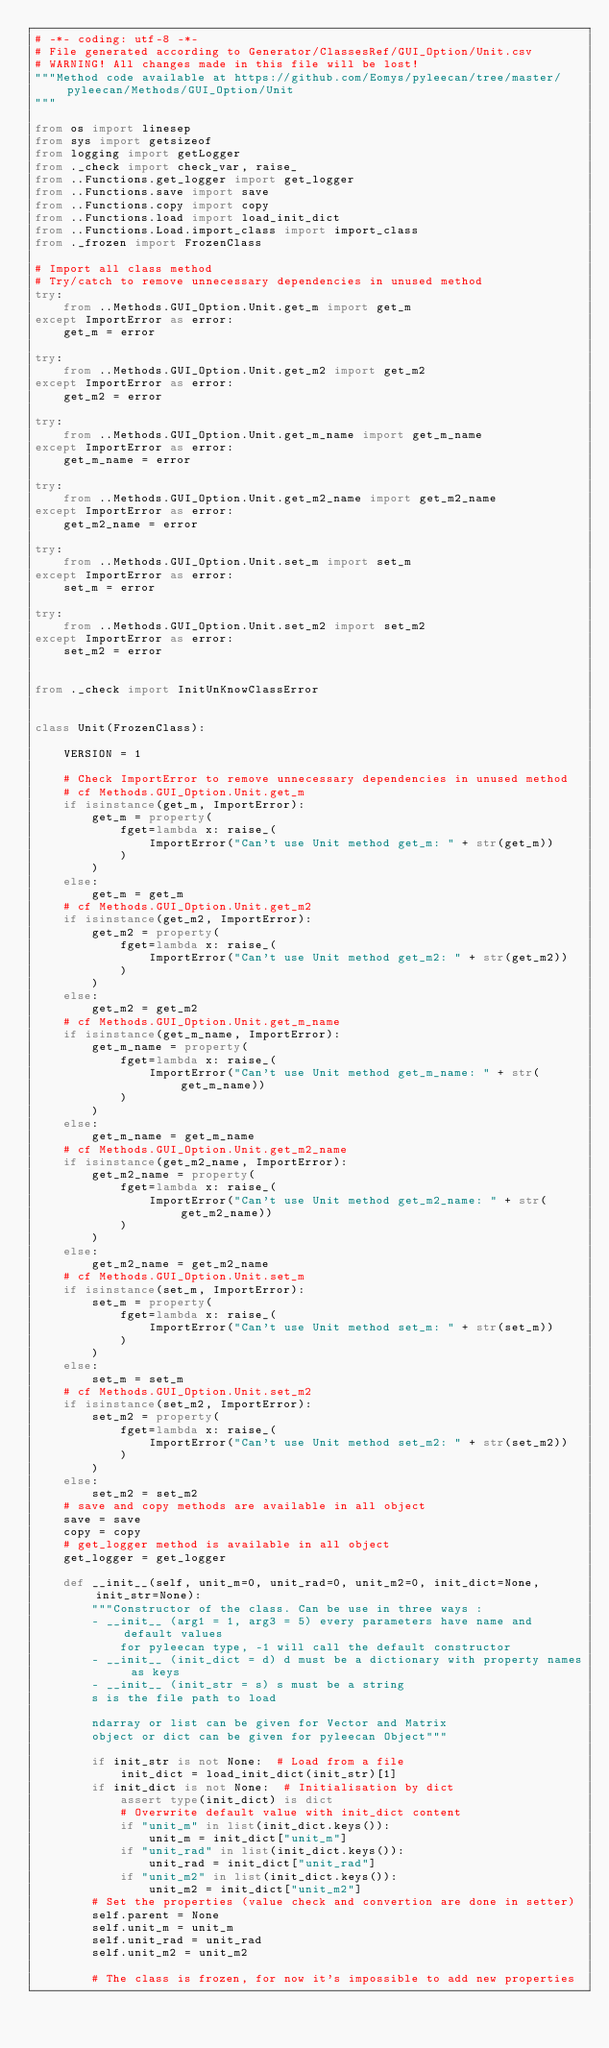Convert code to text. <code><loc_0><loc_0><loc_500><loc_500><_Python_># -*- coding: utf-8 -*-
# File generated according to Generator/ClassesRef/GUI_Option/Unit.csv
# WARNING! All changes made in this file will be lost!
"""Method code available at https://github.com/Eomys/pyleecan/tree/master/pyleecan/Methods/GUI_Option/Unit
"""

from os import linesep
from sys import getsizeof
from logging import getLogger
from ._check import check_var, raise_
from ..Functions.get_logger import get_logger
from ..Functions.save import save
from ..Functions.copy import copy
from ..Functions.load import load_init_dict
from ..Functions.Load.import_class import import_class
from ._frozen import FrozenClass

# Import all class method
# Try/catch to remove unnecessary dependencies in unused method
try:
    from ..Methods.GUI_Option.Unit.get_m import get_m
except ImportError as error:
    get_m = error

try:
    from ..Methods.GUI_Option.Unit.get_m2 import get_m2
except ImportError as error:
    get_m2 = error

try:
    from ..Methods.GUI_Option.Unit.get_m_name import get_m_name
except ImportError as error:
    get_m_name = error

try:
    from ..Methods.GUI_Option.Unit.get_m2_name import get_m2_name
except ImportError as error:
    get_m2_name = error

try:
    from ..Methods.GUI_Option.Unit.set_m import set_m
except ImportError as error:
    set_m = error

try:
    from ..Methods.GUI_Option.Unit.set_m2 import set_m2
except ImportError as error:
    set_m2 = error


from ._check import InitUnKnowClassError


class Unit(FrozenClass):

    VERSION = 1

    # Check ImportError to remove unnecessary dependencies in unused method
    # cf Methods.GUI_Option.Unit.get_m
    if isinstance(get_m, ImportError):
        get_m = property(
            fget=lambda x: raise_(
                ImportError("Can't use Unit method get_m: " + str(get_m))
            )
        )
    else:
        get_m = get_m
    # cf Methods.GUI_Option.Unit.get_m2
    if isinstance(get_m2, ImportError):
        get_m2 = property(
            fget=lambda x: raise_(
                ImportError("Can't use Unit method get_m2: " + str(get_m2))
            )
        )
    else:
        get_m2 = get_m2
    # cf Methods.GUI_Option.Unit.get_m_name
    if isinstance(get_m_name, ImportError):
        get_m_name = property(
            fget=lambda x: raise_(
                ImportError("Can't use Unit method get_m_name: " + str(get_m_name))
            )
        )
    else:
        get_m_name = get_m_name
    # cf Methods.GUI_Option.Unit.get_m2_name
    if isinstance(get_m2_name, ImportError):
        get_m2_name = property(
            fget=lambda x: raise_(
                ImportError("Can't use Unit method get_m2_name: " + str(get_m2_name))
            )
        )
    else:
        get_m2_name = get_m2_name
    # cf Methods.GUI_Option.Unit.set_m
    if isinstance(set_m, ImportError):
        set_m = property(
            fget=lambda x: raise_(
                ImportError("Can't use Unit method set_m: " + str(set_m))
            )
        )
    else:
        set_m = set_m
    # cf Methods.GUI_Option.Unit.set_m2
    if isinstance(set_m2, ImportError):
        set_m2 = property(
            fget=lambda x: raise_(
                ImportError("Can't use Unit method set_m2: " + str(set_m2))
            )
        )
    else:
        set_m2 = set_m2
    # save and copy methods are available in all object
    save = save
    copy = copy
    # get_logger method is available in all object
    get_logger = get_logger

    def __init__(self, unit_m=0, unit_rad=0, unit_m2=0, init_dict=None, init_str=None):
        """Constructor of the class. Can be use in three ways :
        - __init__ (arg1 = 1, arg3 = 5) every parameters have name and default values
            for pyleecan type, -1 will call the default constructor
        - __init__ (init_dict = d) d must be a dictionary with property names as keys
        - __init__ (init_str = s) s must be a string
        s is the file path to load

        ndarray or list can be given for Vector and Matrix
        object or dict can be given for pyleecan Object"""

        if init_str is not None:  # Load from a file
            init_dict = load_init_dict(init_str)[1]
        if init_dict is not None:  # Initialisation by dict
            assert type(init_dict) is dict
            # Overwrite default value with init_dict content
            if "unit_m" in list(init_dict.keys()):
                unit_m = init_dict["unit_m"]
            if "unit_rad" in list(init_dict.keys()):
                unit_rad = init_dict["unit_rad"]
            if "unit_m2" in list(init_dict.keys()):
                unit_m2 = init_dict["unit_m2"]
        # Set the properties (value check and convertion are done in setter)
        self.parent = None
        self.unit_m = unit_m
        self.unit_rad = unit_rad
        self.unit_m2 = unit_m2

        # The class is frozen, for now it's impossible to add new properties</code> 